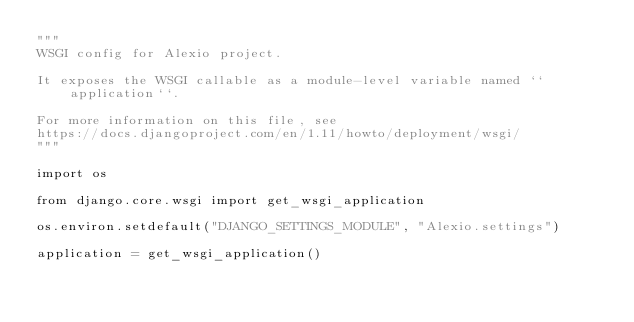Convert code to text. <code><loc_0><loc_0><loc_500><loc_500><_Python_>"""
WSGI config for Alexio project.

It exposes the WSGI callable as a module-level variable named ``application``.

For more information on this file, see
https://docs.djangoproject.com/en/1.11/howto/deployment/wsgi/
"""

import os

from django.core.wsgi import get_wsgi_application

os.environ.setdefault("DJANGO_SETTINGS_MODULE", "Alexio.settings")

application = get_wsgi_application()
</code> 